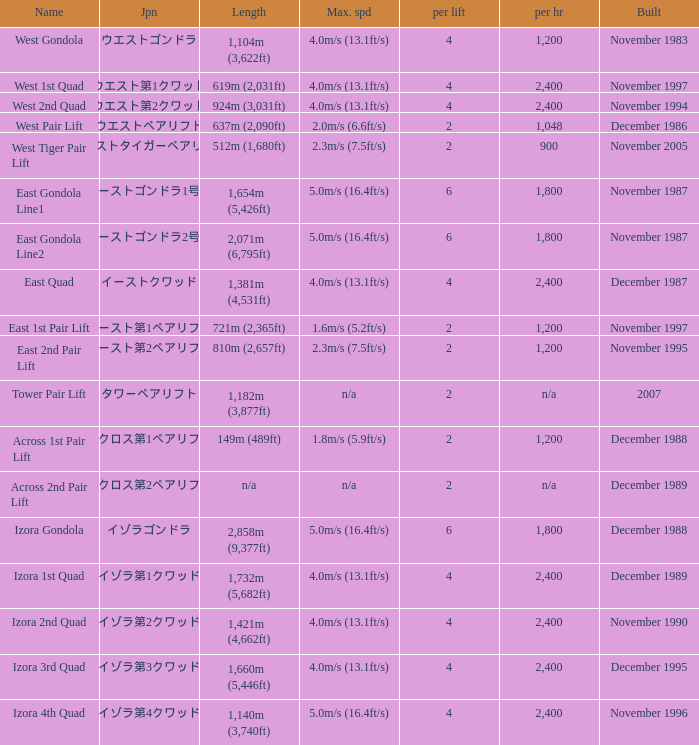How heavy is the  maximum 6.0. 